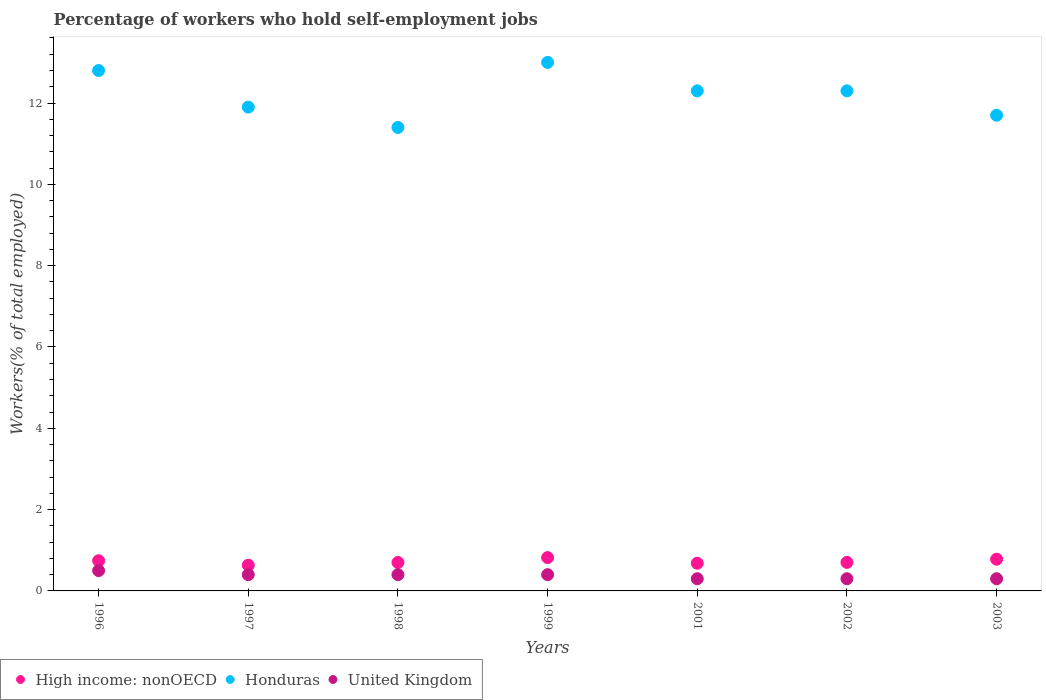Is the number of dotlines equal to the number of legend labels?
Your answer should be compact. Yes. What is the percentage of self-employed workers in High income: nonOECD in 1997?
Ensure brevity in your answer.  0.63. Across all years, what is the maximum percentage of self-employed workers in United Kingdom?
Provide a short and direct response. 0.5. Across all years, what is the minimum percentage of self-employed workers in High income: nonOECD?
Provide a short and direct response. 0.63. What is the total percentage of self-employed workers in Honduras in the graph?
Ensure brevity in your answer.  85.4. What is the difference between the percentage of self-employed workers in United Kingdom in 1998 and that in 2002?
Keep it short and to the point. 0.1. What is the difference between the percentage of self-employed workers in High income: nonOECD in 2003 and the percentage of self-employed workers in United Kingdom in 1999?
Your response must be concise. 0.38. What is the average percentage of self-employed workers in United Kingdom per year?
Your answer should be very brief. 0.37. In the year 1996, what is the difference between the percentage of self-employed workers in High income: nonOECD and percentage of self-employed workers in United Kingdom?
Make the answer very short. 0.24. In how many years, is the percentage of self-employed workers in Honduras greater than 4 %?
Give a very brief answer. 7. What is the ratio of the percentage of self-employed workers in Honduras in 1998 to that in 1999?
Make the answer very short. 0.88. What is the difference between the highest and the second highest percentage of self-employed workers in Honduras?
Give a very brief answer. 0.2. What is the difference between the highest and the lowest percentage of self-employed workers in Honduras?
Offer a very short reply. 1.6. In how many years, is the percentage of self-employed workers in High income: nonOECD greater than the average percentage of self-employed workers in High income: nonOECD taken over all years?
Provide a succinct answer. 3. Is it the case that in every year, the sum of the percentage of self-employed workers in High income: nonOECD and percentage of self-employed workers in Honduras  is greater than the percentage of self-employed workers in United Kingdom?
Offer a terse response. Yes. Is the percentage of self-employed workers in High income: nonOECD strictly greater than the percentage of self-employed workers in United Kingdom over the years?
Provide a succinct answer. Yes. Is the percentage of self-employed workers in High income: nonOECD strictly less than the percentage of self-employed workers in Honduras over the years?
Your answer should be very brief. Yes. Does the graph contain grids?
Offer a terse response. No. Where does the legend appear in the graph?
Make the answer very short. Bottom left. What is the title of the graph?
Give a very brief answer. Percentage of workers who hold self-employment jobs. Does "Somalia" appear as one of the legend labels in the graph?
Your answer should be very brief. No. What is the label or title of the Y-axis?
Provide a short and direct response. Workers(% of total employed). What is the Workers(% of total employed) in High income: nonOECD in 1996?
Offer a terse response. 0.74. What is the Workers(% of total employed) in Honduras in 1996?
Make the answer very short. 12.8. What is the Workers(% of total employed) of High income: nonOECD in 1997?
Your answer should be compact. 0.63. What is the Workers(% of total employed) in Honduras in 1997?
Make the answer very short. 11.9. What is the Workers(% of total employed) of United Kingdom in 1997?
Give a very brief answer. 0.4. What is the Workers(% of total employed) of High income: nonOECD in 1998?
Your answer should be compact. 0.7. What is the Workers(% of total employed) in Honduras in 1998?
Give a very brief answer. 11.4. What is the Workers(% of total employed) of United Kingdom in 1998?
Ensure brevity in your answer.  0.4. What is the Workers(% of total employed) of High income: nonOECD in 1999?
Your answer should be compact. 0.82. What is the Workers(% of total employed) in Honduras in 1999?
Make the answer very short. 13. What is the Workers(% of total employed) of United Kingdom in 1999?
Offer a terse response. 0.4. What is the Workers(% of total employed) of High income: nonOECD in 2001?
Offer a very short reply. 0.68. What is the Workers(% of total employed) in Honduras in 2001?
Your answer should be compact. 12.3. What is the Workers(% of total employed) of United Kingdom in 2001?
Provide a succinct answer. 0.3. What is the Workers(% of total employed) in High income: nonOECD in 2002?
Offer a very short reply. 0.7. What is the Workers(% of total employed) of Honduras in 2002?
Offer a terse response. 12.3. What is the Workers(% of total employed) in United Kingdom in 2002?
Give a very brief answer. 0.3. What is the Workers(% of total employed) of High income: nonOECD in 2003?
Your response must be concise. 0.78. What is the Workers(% of total employed) in Honduras in 2003?
Make the answer very short. 11.7. What is the Workers(% of total employed) in United Kingdom in 2003?
Your response must be concise. 0.3. Across all years, what is the maximum Workers(% of total employed) in High income: nonOECD?
Keep it short and to the point. 0.82. Across all years, what is the minimum Workers(% of total employed) of High income: nonOECD?
Your response must be concise. 0.63. Across all years, what is the minimum Workers(% of total employed) of Honduras?
Keep it short and to the point. 11.4. Across all years, what is the minimum Workers(% of total employed) of United Kingdom?
Ensure brevity in your answer.  0.3. What is the total Workers(% of total employed) of High income: nonOECD in the graph?
Provide a short and direct response. 5.06. What is the total Workers(% of total employed) in Honduras in the graph?
Keep it short and to the point. 85.4. What is the total Workers(% of total employed) of United Kingdom in the graph?
Ensure brevity in your answer.  2.6. What is the difference between the Workers(% of total employed) in High income: nonOECD in 1996 and that in 1997?
Your answer should be very brief. 0.11. What is the difference between the Workers(% of total employed) in Honduras in 1996 and that in 1997?
Offer a terse response. 0.9. What is the difference between the Workers(% of total employed) of High income: nonOECD in 1996 and that in 1998?
Make the answer very short. 0.04. What is the difference between the Workers(% of total employed) in United Kingdom in 1996 and that in 1998?
Your answer should be compact. 0.1. What is the difference between the Workers(% of total employed) in High income: nonOECD in 1996 and that in 1999?
Your response must be concise. -0.08. What is the difference between the Workers(% of total employed) of United Kingdom in 1996 and that in 1999?
Make the answer very short. 0.1. What is the difference between the Workers(% of total employed) in High income: nonOECD in 1996 and that in 2001?
Make the answer very short. 0.06. What is the difference between the Workers(% of total employed) of High income: nonOECD in 1996 and that in 2002?
Your answer should be very brief. 0.04. What is the difference between the Workers(% of total employed) in Honduras in 1996 and that in 2002?
Your response must be concise. 0.5. What is the difference between the Workers(% of total employed) of High income: nonOECD in 1996 and that in 2003?
Your answer should be compact. -0.04. What is the difference between the Workers(% of total employed) in Honduras in 1996 and that in 2003?
Ensure brevity in your answer.  1.1. What is the difference between the Workers(% of total employed) of United Kingdom in 1996 and that in 2003?
Keep it short and to the point. 0.2. What is the difference between the Workers(% of total employed) in High income: nonOECD in 1997 and that in 1998?
Offer a terse response. -0.07. What is the difference between the Workers(% of total employed) of United Kingdom in 1997 and that in 1998?
Your answer should be compact. 0. What is the difference between the Workers(% of total employed) of High income: nonOECD in 1997 and that in 1999?
Your answer should be very brief. -0.19. What is the difference between the Workers(% of total employed) in Honduras in 1997 and that in 1999?
Provide a short and direct response. -1.1. What is the difference between the Workers(% of total employed) in High income: nonOECD in 1997 and that in 2001?
Provide a short and direct response. -0.05. What is the difference between the Workers(% of total employed) in High income: nonOECD in 1997 and that in 2002?
Provide a short and direct response. -0.07. What is the difference between the Workers(% of total employed) in United Kingdom in 1997 and that in 2002?
Your response must be concise. 0.1. What is the difference between the Workers(% of total employed) of High income: nonOECD in 1997 and that in 2003?
Your answer should be very brief. -0.15. What is the difference between the Workers(% of total employed) in Honduras in 1997 and that in 2003?
Ensure brevity in your answer.  0.2. What is the difference between the Workers(% of total employed) in United Kingdom in 1997 and that in 2003?
Offer a terse response. 0.1. What is the difference between the Workers(% of total employed) in High income: nonOECD in 1998 and that in 1999?
Your answer should be compact. -0.12. What is the difference between the Workers(% of total employed) in Honduras in 1998 and that in 1999?
Provide a succinct answer. -1.6. What is the difference between the Workers(% of total employed) in High income: nonOECD in 1998 and that in 2001?
Give a very brief answer. 0.02. What is the difference between the Workers(% of total employed) in Honduras in 1998 and that in 2001?
Provide a short and direct response. -0.9. What is the difference between the Workers(% of total employed) of High income: nonOECD in 1998 and that in 2002?
Provide a short and direct response. -0. What is the difference between the Workers(% of total employed) of Honduras in 1998 and that in 2002?
Your response must be concise. -0.9. What is the difference between the Workers(% of total employed) in United Kingdom in 1998 and that in 2002?
Your answer should be very brief. 0.1. What is the difference between the Workers(% of total employed) in High income: nonOECD in 1998 and that in 2003?
Your answer should be compact. -0.08. What is the difference between the Workers(% of total employed) of Honduras in 1998 and that in 2003?
Your response must be concise. -0.3. What is the difference between the Workers(% of total employed) in United Kingdom in 1998 and that in 2003?
Your answer should be very brief. 0.1. What is the difference between the Workers(% of total employed) in High income: nonOECD in 1999 and that in 2001?
Offer a very short reply. 0.14. What is the difference between the Workers(% of total employed) in United Kingdom in 1999 and that in 2001?
Your answer should be very brief. 0.1. What is the difference between the Workers(% of total employed) in High income: nonOECD in 1999 and that in 2002?
Offer a very short reply. 0.12. What is the difference between the Workers(% of total employed) in Honduras in 1999 and that in 2002?
Keep it short and to the point. 0.7. What is the difference between the Workers(% of total employed) of High income: nonOECD in 1999 and that in 2003?
Your answer should be very brief. 0.04. What is the difference between the Workers(% of total employed) in Honduras in 1999 and that in 2003?
Give a very brief answer. 1.3. What is the difference between the Workers(% of total employed) in High income: nonOECD in 2001 and that in 2002?
Provide a short and direct response. -0.02. What is the difference between the Workers(% of total employed) in Honduras in 2001 and that in 2002?
Give a very brief answer. 0. What is the difference between the Workers(% of total employed) in United Kingdom in 2001 and that in 2002?
Ensure brevity in your answer.  0. What is the difference between the Workers(% of total employed) in High income: nonOECD in 2001 and that in 2003?
Keep it short and to the point. -0.1. What is the difference between the Workers(% of total employed) in United Kingdom in 2001 and that in 2003?
Provide a succinct answer. 0. What is the difference between the Workers(% of total employed) of High income: nonOECD in 2002 and that in 2003?
Ensure brevity in your answer.  -0.08. What is the difference between the Workers(% of total employed) of United Kingdom in 2002 and that in 2003?
Give a very brief answer. 0. What is the difference between the Workers(% of total employed) of High income: nonOECD in 1996 and the Workers(% of total employed) of Honduras in 1997?
Offer a very short reply. -11.16. What is the difference between the Workers(% of total employed) of High income: nonOECD in 1996 and the Workers(% of total employed) of United Kingdom in 1997?
Provide a short and direct response. 0.34. What is the difference between the Workers(% of total employed) in Honduras in 1996 and the Workers(% of total employed) in United Kingdom in 1997?
Your answer should be compact. 12.4. What is the difference between the Workers(% of total employed) in High income: nonOECD in 1996 and the Workers(% of total employed) in Honduras in 1998?
Offer a very short reply. -10.66. What is the difference between the Workers(% of total employed) in High income: nonOECD in 1996 and the Workers(% of total employed) in United Kingdom in 1998?
Make the answer very short. 0.34. What is the difference between the Workers(% of total employed) of High income: nonOECD in 1996 and the Workers(% of total employed) of Honduras in 1999?
Make the answer very short. -12.26. What is the difference between the Workers(% of total employed) in High income: nonOECD in 1996 and the Workers(% of total employed) in United Kingdom in 1999?
Your answer should be very brief. 0.34. What is the difference between the Workers(% of total employed) in High income: nonOECD in 1996 and the Workers(% of total employed) in Honduras in 2001?
Ensure brevity in your answer.  -11.56. What is the difference between the Workers(% of total employed) in High income: nonOECD in 1996 and the Workers(% of total employed) in United Kingdom in 2001?
Make the answer very short. 0.44. What is the difference between the Workers(% of total employed) in Honduras in 1996 and the Workers(% of total employed) in United Kingdom in 2001?
Your answer should be compact. 12.5. What is the difference between the Workers(% of total employed) in High income: nonOECD in 1996 and the Workers(% of total employed) in Honduras in 2002?
Offer a terse response. -11.56. What is the difference between the Workers(% of total employed) of High income: nonOECD in 1996 and the Workers(% of total employed) of United Kingdom in 2002?
Your answer should be very brief. 0.44. What is the difference between the Workers(% of total employed) of Honduras in 1996 and the Workers(% of total employed) of United Kingdom in 2002?
Make the answer very short. 12.5. What is the difference between the Workers(% of total employed) of High income: nonOECD in 1996 and the Workers(% of total employed) of Honduras in 2003?
Provide a succinct answer. -10.96. What is the difference between the Workers(% of total employed) of High income: nonOECD in 1996 and the Workers(% of total employed) of United Kingdom in 2003?
Keep it short and to the point. 0.44. What is the difference between the Workers(% of total employed) in Honduras in 1996 and the Workers(% of total employed) in United Kingdom in 2003?
Ensure brevity in your answer.  12.5. What is the difference between the Workers(% of total employed) of High income: nonOECD in 1997 and the Workers(% of total employed) of Honduras in 1998?
Your answer should be compact. -10.77. What is the difference between the Workers(% of total employed) in High income: nonOECD in 1997 and the Workers(% of total employed) in United Kingdom in 1998?
Your answer should be compact. 0.23. What is the difference between the Workers(% of total employed) of Honduras in 1997 and the Workers(% of total employed) of United Kingdom in 1998?
Ensure brevity in your answer.  11.5. What is the difference between the Workers(% of total employed) in High income: nonOECD in 1997 and the Workers(% of total employed) in Honduras in 1999?
Provide a short and direct response. -12.37. What is the difference between the Workers(% of total employed) of High income: nonOECD in 1997 and the Workers(% of total employed) of United Kingdom in 1999?
Offer a terse response. 0.23. What is the difference between the Workers(% of total employed) in High income: nonOECD in 1997 and the Workers(% of total employed) in Honduras in 2001?
Offer a terse response. -11.67. What is the difference between the Workers(% of total employed) in High income: nonOECD in 1997 and the Workers(% of total employed) in United Kingdom in 2001?
Your response must be concise. 0.33. What is the difference between the Workers(% of total employed) in Honduras in 1997 and the Workers(% of total employed) in United Kingdom in 2001?
Provide a short and direct response. 11.6. What is the difference between the Workers(% of total employed) of High income: nonOECD in 1997 and the Workers(% of total employed) of Honduras in 2002?
Your answer should be very brief. -11.67. What is the difference between the Workers(% of total employed) of High income: nonOECD in 1997 and the Workers(% of total employed) of United Kingdom in 2002?
Offer a very short reply. 0.33. What is the difference between the Workers(% of total employed) of High income: nonOECD in 1997 and the Workers(% of total employed) of Honduras in 2003?
Provide a short and direct response. -11.07. What is the difference between the Workers(% of total employed) in High income: nonOECD in 1997 and the Workers(% of total employed) in United Kingdom in 2003?
Make the answer very short. 0.33. What is the difference between the Workers(% of total employed) of Honduras in 1997 and the Workers(% of total employed) of United Kingdom in 2003?
Your answer should be very brief. 11.6. What is the difference between the Workers(% of total employed) of High income: nonOECD in 1998 and the Workers(% of total employed) of Honduras in 1999?
Keep it short and to the point. -12.3. What is the difference between the Workers(% of total employed) of High income: nonOECD in 1998 and the Workers(% of total employed) of United Kingdom in 1999?
Your response must be concise. 0.3. What is the difference between the Workers(% of total employed) of High income: nonOECD in 1998 and the Workers(% of total employed) of Honduras in 2001?
Give a very brief answer. -11.6. What is the difference between the Workers(% of total employed) in High income: nonOECD in 1998 and the Workers(% of total employed) in United Kingdom in 2001?
Offer a very short reply. 0.4. What is the difference between the Workers(% of total employed) in Honduras in 1998 and the Workers(% of total employed) in United Kingdom in 2001?
Make the answer very short. 11.1. What is the difference between the Workers(% of total employed) of High income: nonOECD in 1998 and the Workers(% of total employed) of Honduras in 2002?
Offer a very short reply. -11.6. What is the difference between the Workers(% of total employed) in High income: nonOECD in 1998 and the Workers(% of total employed) in United Kingdom in 2002?
Your answer should be very brief. 0.4. What is the difference between the Workers(% of total employed) of Honduras in 1998 and the Workers(% of total employed) of United Kingdom in 2002?
Your answer should be compact. 11.1. What is the difference between the Workers(% of total employed) in High income: nonOECD in 1998 and the Workers(% of total employed) in Honduras in 2003?
Your answer should be compact. -11. What is the difference between the Workers(% of total employed) in High income: nonOECD in 1998 and the Workers(% of total employed) in United Kingdom in 2003?
Offer a very short reply. 0.4. What is the difference between the Workers(% of total employed) in Honduras in 1998 and the Workers(% of total employed) in United Kingdom in 2003?
Your response must be concise. 11.1. What is the difference between the Workers(% of total employed) in High income: nonOECD in 1999 and the Workers(% of total employed) in Honduras in 2001?
Make the answer very short. -11.48. What is the difference between the Workers(% of total employed) in High income: nonOECD in 1999 and the Workers(% of total employed) in United Kingdom in 2001?
Make the answer very short. 0.52. What is the difference between the Workers(% of total employed) in Honduras in 1999 and the Workers(% of total employed) in United Kingdom in 2001?
Offer a terse response. 12.7. What is the difference between the Workers(% of total employed) of High income: nonOECD in 1999 and the Workers(% of total employed) of Honduras in 2002?
Offer a terse response. -11.48. What is the difference between the Workers(% of total employed) in High income: nonOECD in 1999 and the Workers(% of total employed) in United Kingdom in 2002?
Keep it short and to the point. 0.52. What is the difference between the Workers(% of total employed) in Honduras in 1999 and the Workers(% of total employed) in United Kingdom in 2002?
Offer a terse response. 12.7. What is the difference between the Workers(% of total employed) of High income: nonOECD in 1999 and the Workers(% of total employed) of Honduras in 2003?
Provide a short and direct response. -10.88. What is the difference between the Workers(% of total employed) in High income: nonOECD in 1999 and the Workers(% of total employed) in United Kingdom in 2003?
Make the answer very short. 0.52. What is the difference between the Workers(% of total employed) in High income: nonOECD in 2001 and the Workers(% of total employed) in Honduras in 2002?
Your response must be concise. -11.62. What is the difference between the Workers(% of total employed) in High income: nonOECD in 2001 and the Workers(% of total employed) in United Kingdom in 2002?
Keep it short and to the point. 0.38. What is the difference between the Workers(% of total employed) in Honduras in 2001 and the Workers(% of total employed) in United Kingdom in 2002?
Give a very brief answer. 12. What is the difference between the Workers(% of total employed) of High income: nonOECD in 2001 and the Workers(% of total employed) of Honduras in 2003?
Provide a short and direct response. -11.02. What is the difference between the Workers(% of total employed) of High income: nonOECD in 2001 and the Workers(% of total employed) of United Kingdom in 2003?
Your answer should be very brief. 0.38. What is the difference between the Workers(% of total employed) in High income: nonOECD in 2002 and the Workers(% of total employed) in Honduras in 2003?
Offer a very short reply. -11. What is the difference between the Workers(% of total employed) in High income: nonOECD in 2002 and the Workers(% of total employed) in United Kingdom in 2003?
Provide a short and direct response. 0.4. What is the difference between the Workers(% of total employed) in Honduras in 2002 and the Workers(% of total employed) in United Kingdom in 2003?
Your answer should be compact. 12. What is the average Workers(% of total employed) in High income: nonOECD per year?
Provide a short and direct response. 0.72. What is the average Workers(% of total employed) of United Kingdom per year?
Provide a succinct answer. 0.37. In the year 1996, what is the difference between the Workers(% of total employed) of High income: nonOECD and Workers(% of total employed) of Honduras?
Offer a very short reply. -12.06. In the year 1996, what is the difference between the Workers(% of total employed) of High income: nonOECD and Workers(% of total employed) of United Kingdom?
Make the answer very short. 0.24. In the year 1996, what is the difference between the Workers(% of total employed) in Honduras and Workers(% of total employed) in United Kingdom?
Give a very brief answer. 12.3. In the year 1997, what is the difference between the Workers(% of total employed) of High income: nonOECD and Workers(% of total employed) of Honduras?
Your answer should be very brief. -11.27. In the year 1997, what is the difference between the Workers(% of total employed) in High income: nonOECD and Workers(% of total employed) in United Kingdom?
Your answer should be compact. 0.23. In the year 1997, what is the difference between the Workers(% of total employed) in Honduras and Workers(% of total employed) in United Kingdom?
Give a very brief answer. 11.5. In the year 1998, what is the difference between the Workers(% of total employed) of High income: nonOECD and Workers(% of total employed) of Honduras?
Keep it short and to the point. -10.7. In the year 1998, what is the difference between the Workers(% of total employed) in High income: nonOECD and Workers(% of total employed) in United Kingdom?
Provide a short and direct response. 0.3. In the year 1998, what is the difference between the Workers(% of total employed) of Honduras and Workers(% of total employed) of United Kingdom?
Provide a short and direct response. 11. In the year 1999, what is the difference between the Workers(% of total employed) of High income: nonOECD and Workers(% of total employed) of Honduras?
Offer a terse response. -12.18. In the year 1999, what is the difference between the Workers(% of total employed) in High income: nonOECD and Workers(% of total employed) in United Kingdom?
Provide a succinct answer. 0.42. In the year 1999, what is the difference between the Workers(% of total employed) of Honduras and Workers(% of total employed) of United Kingdom?
Your answer should be compact. 12.6. In the year 2001, what is the difference between the Workers(% of total employed) in High income: nonOECD and Workers(% of total employed) in Honduras?
Make the answer very short. -11.62. In the year 2001, what is the difference between the Workers(% of total employed) of High income: nonOECD and Workers(% of total employed) of United Kingdom?
Ensure brevity in your answer.  0.38. In the year 2001, what is the difference between the Workers(% of total employed) of Honduras and Workers(% of total employed) of United Kingdom?
Your answer should be compact. 12. In the year 2002, what is the difference between the Workers(% of total employed) in High income: nonOECD and Workers(% of total employed) in Honduras?
Your response must be concise. -11.6. In the year 2002, what is the difference between the Workers(% of total employed) in High income: nonOECD and Workers(% of total employed) in United Kingdom?
Offer a terse response. 0.4. In the year 2002, what is the difference between the Workers(% of total employed) of Honduras and Workers(% of total employed) of United Kingdom?
Offer a terse response. 12. In the year 2003, what is the difference between the Workers(% of total employed) of High income: nonOECD and Workers(% of total employed) of Honduras?
Your response must be concise. -10.92. In the year 2003, what is the difference between the Workers(% of total employed) of High income: nonOECD and Workers(% of total employed) of United Kingdom?
Keep it short and to the point. 0.48. What is the ratio of the Workers(% of total employed) of High income: nonOECD in 1996 to that in 1997?
Offer a very short reply. 1.17. What is the ratio of the Workers(% of total employed) in Honduras in 1996 to that in 1997?
Offer a terse response. 1.08. What is the ratio of the Workers(% of total employed) of High income: nonOECD in 1996 to that in 1998?
Provide a short and direct response. 1.06. What is the ratio of the Workers(% of total employed) of Honduras in 1996 to that in 1998?
Offer a very short reply. 1.12. What is the ratio of the Workers(% of total employed) of High income: nonOECD in 1996 to that in 1999?
Your answer should be very brief. 0.91. What is the ratio of the Workers(% of total employed) of Honduras in 1996 to that in 1999?
Provide a short and direct response. 0.98. What is the ratio of the Workers(% of total employed) in United Kingdom in 1996 to that in 1999?
Your answer should be compact. 1.25. What is the ratio of the Workers(% of total employed) in High income: nonOECD in 1996 to that in 2001?
Keep it short and to the point. 1.09. What is the ratio of the Workers(% of total employed) in Honduras in 1996 to that in 2001?
Offer a terse response. 1.04. What is the ratio of the Workers(% of total employed) in United Kingdom in 1996 to that in 2001?
Offer a very short reply. 1.67. What is the ratio of the Workers(% of total employed) of High income: nonOECD in 1996 to that in 2002?
Give a very brief answer. 1.06. What is the ratio of the Workers(% of total employed) in Honduras in 1996 to that in 2002?
Keep it short and to the point. 1.04. What is the ratio of the Workers(% of total employed) of United Kingdom in 1996 to that in 2002?
Give a very brief answer. 1.67. What is the ratio of the Workers(% of total employed) in High income: nonOECD in 1996 to that in 2003?
Provide a short and direct response. 0.95. What is the ratio of the Workers(% of total employed) of Honduras in 1996 to that in 2003?
Keep it short and to the point. 1.09. What is the ratio of the Workers(% of total employed) in United Kingdom in 1996 to that in 2003?
Your answer should be very brief. 1.67. What is the ratio of the Workers(% of total employed) of High income: nonOECD in 1997 to that in 1998?
Offer a very short reply. 0.9. What is the ratio of the Workers(% of total employed) of Honduras in 1997 to that in 1998?
Keep it short and to the point. 1.04. What is the ratio of the Workers(% of total employed) of High income: nonOECD in 1997 to that in 1999?
Make the answer very short. 0.77. What is the ratio of the Workers(% of total employed) in Honduras in 1997 to that in 1999?
Offer a terse response. 0.92. What is the ratio of the Workers(% of total employed) in High income: nonOECD in 1997 to that in 2001?
Provide a succinct answer. 0.93. What is the ratio of the Workers(% of total employed) of Honduras in 1997 to that in 2001?
Your answer should be compact. 0.97. What is the ratio of the Workers(% of total employed) in High income: nonOECD in 1997 to that in 2002?
Offer a terse response. 0.9. What is the ratio of the Workers(% of total employed) of Honduras in 1997 to that in 2002?
Make the answer very short. 0.97. What is the ratio of the Workers(% of total employed) in High income: nonOECD in 1997 to that in 2003?
Make the answer very short. 0.81. What is the ratio of the Workers(% of total employed) of Honduras in 1997 to that in 2003?
Offer a terse response. 1.02. What is the ratio of the Workers(% of total employed) of High income: nonOECD in 1998 to that in 1999?
Provide a succinct answer. 0.85. What is the ratio of the Workers(% of total employed) in Honduras in 1998 to that in 1999?
Your answer should be very brief. 0.88. What is the ratio of the Workers(% of total employed) in High income: nonOECD in 1998 to that in 2001?
Your response must be concise. 1.03. What is the ratio of the Workers(% of total employed) of Honduras in 1998 to that in 2001?
Ensure brevity in your answer.  0.93. What is the ratio of the Workers(% of total employed) of United Kingdom in 1998 to that in 2001?
Your response must be concise. 1.33. What is the ratio of the Workers(% of total employed) in Honduras in 1998 to that in 2002?
Offer a very short reply. 0.93. What is the ratio of the Workers(% of total employed) in High income: nonOECD in 1998 to that in 2003?
Give a very brief answer. 0.9. What is the ratio of the Workers(% of total employed) of Honduras in 1998 to that in 2003?
Ensure brevity in your answer.  0.97. What is the ratio of the Workers(% of total employed) of United Kingdom in 1998 to that in 2003?
Offer a very short reply. 1.33. What is the ratio of the Workers(% of total employed) in High income: nonOECD in 1999 to that in 2001?
Ensure brevity in your answer.  1.2. What is the ratio of the Workers(% of total employed) in Honduras in 1999 to that in 2001?
Offer a terse response. 1.06. What is the ratio of the Workers(% of total employed) in High income: nonOECD in 1999 to that in 2002?
Make the answer very short. 1.17. What is the ratio of the Workers(% of total employed) of Honduras in 1999 to that in 2002?
Provide a short and direct response. 1.06. What is the ratio of the Workers(% of total employed) in High income: nonOECD in 1999 to that in 2003?
Ensure brevity in your answer.  1.05. What is the ratio of the Workers(% of total employed) in High income: nonOECD in 2001 to that in 2002?
Keep it short and to the point. 0.97. What is the ratio of the Workers(% of total employed) in Honduras in 2001 to that in 2002?
Ensure brevity in your answer.  1. What is the ratio of the Workers(% of total employed) of United Kingdom in 2001 to that in 2002?
Your answer should be very brief. 1. What is the ratio of the Workers(% of total employed) in High income: nonOECD in 2001 to that in 2003?
Offer a terse response. 0.87. What is the ratio of the Workers(% of total employed) in Honduras in 2001 to that in 2003?
Offer a terse response. 1.05. What is the ratio of the Workers(% of total employed) of High income: nonOECD in 2002 to that in 2003?
Your response must be concise. 0.9. What is the ratio of the Workers(% of total employed) in Honduras in 2002 to that in 2003?
Provide a succinct answer. 1.05. What is the ratio of the Workers(% of total employed) of United Kingdom in 2002 to that in 2003?
Your response must be concise. 1. What is the difference between the highest and the second highest Workers(% of total employed) of High income: nonOECD?
Provide a short and direct response. 0.04. What is the difference between the highest and the lowest Workers(% of total employed) of High income: nonOECD?
Provide a short and direct response. 0.19. 